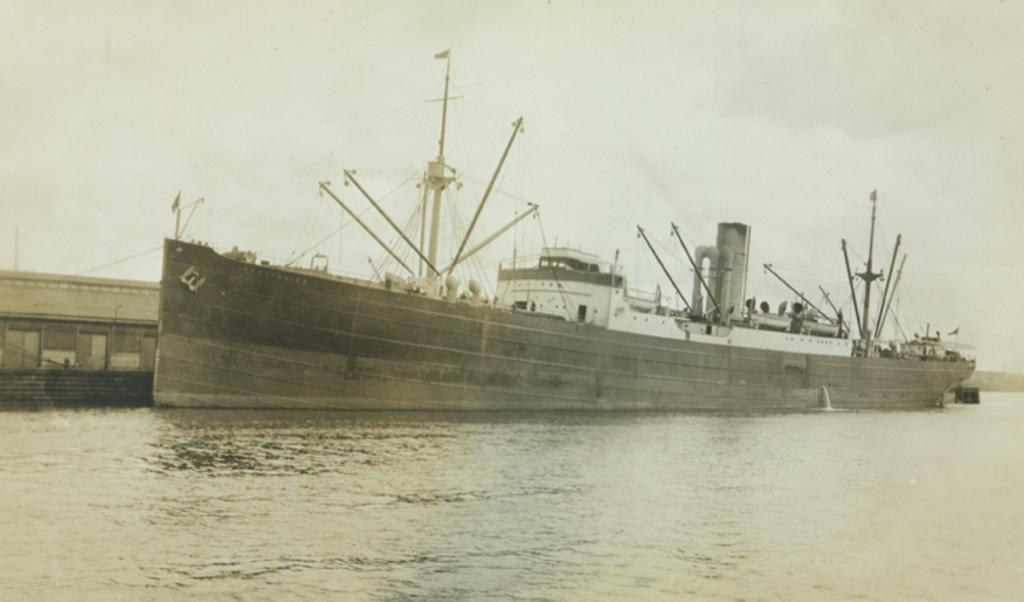What is the main subject of the image? The main subject of the image is a ship. Where is the ship located? The ship is in the water. What can be seen near the ship? There are poles near the ship, as well as other unspecified things. What year is depicted in the image? The provided facts do not mention any specific year, so it cannot be determined from the image. How many ears can be seen on the ship in the image? There are no ears present in the image, as it features a ship and its surroundings. 